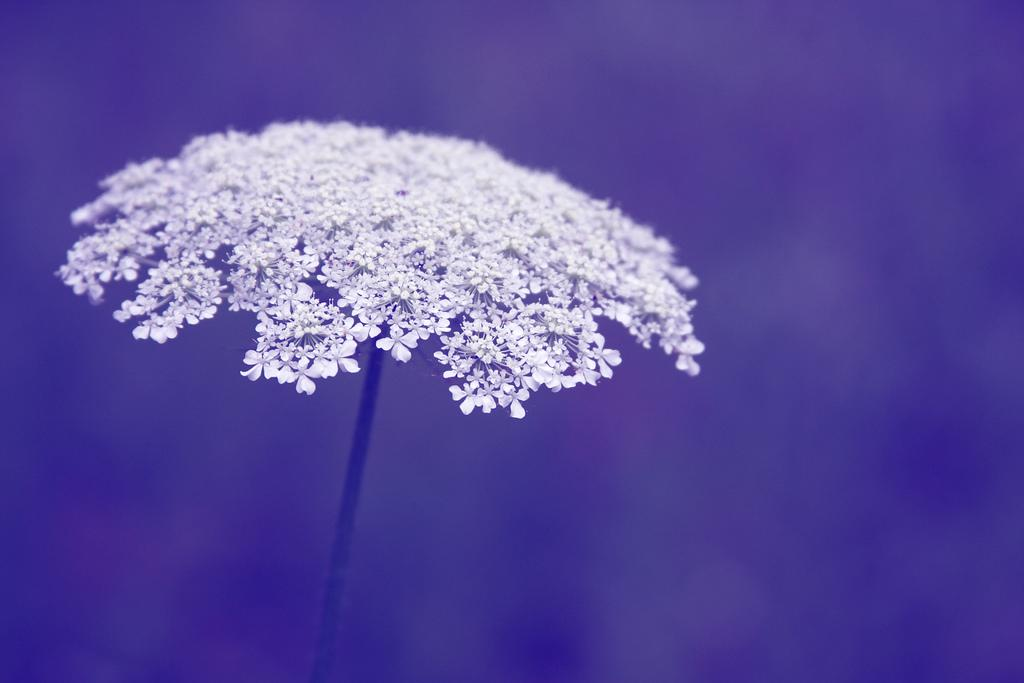What type of flowers can be seen in the image? There are white color flowers in the image. Are there any spiders fighting on the flowers in the image? There is no mention of spiders or fighting in the image, and therefore no such activity can be observed. 